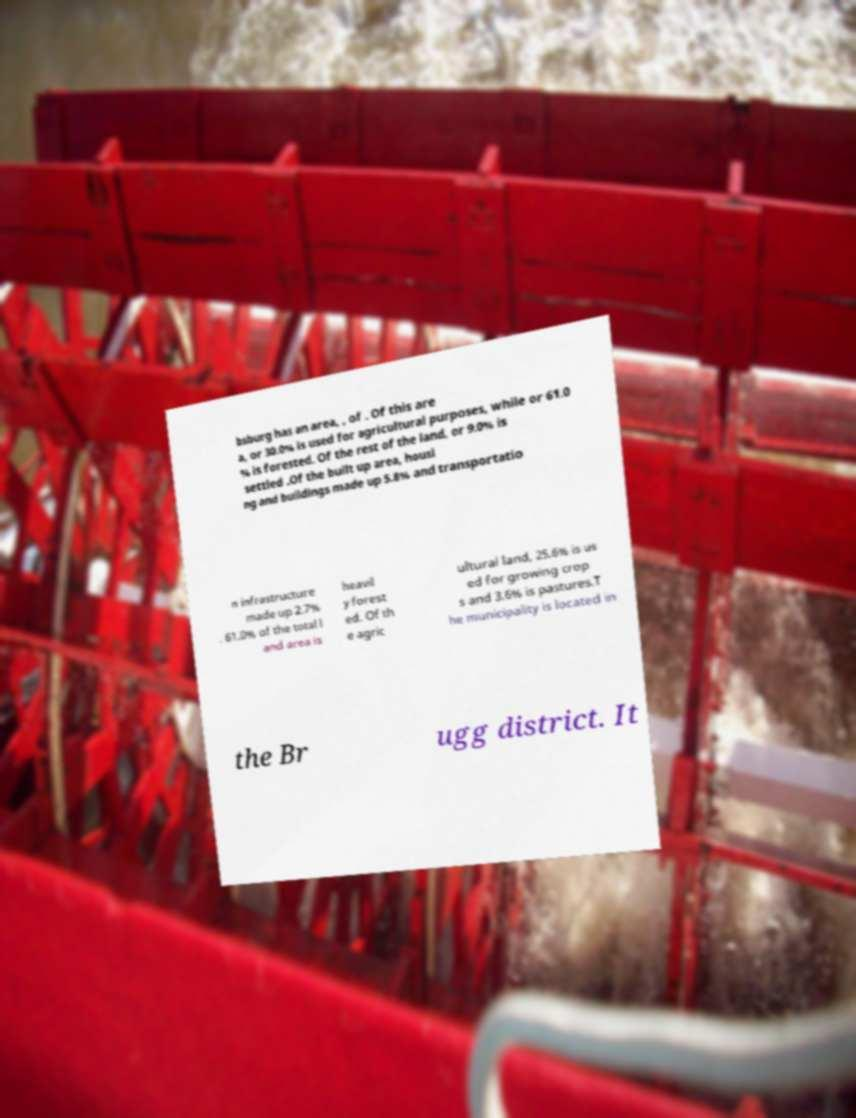For documentation purposes, I need the text within this image transcribed. Could you provide that? bsburg has an area, , of . Of this are a, or 30.0% is used for agricultural purposes, while or 61.0 % is forested. Of the rest of the land, or 9.0% is settled .Of the built up area, housi ng and buildings made up 5.8% and transportatio n infrastructure made up 2.7% . 61.0% of the total l and area is heavil y forest ed. Of th e agric ultural land, 25.6% is us ed for growing crop s and 3.6% is pastures.T he municipality is located in the Br ugg district. It 